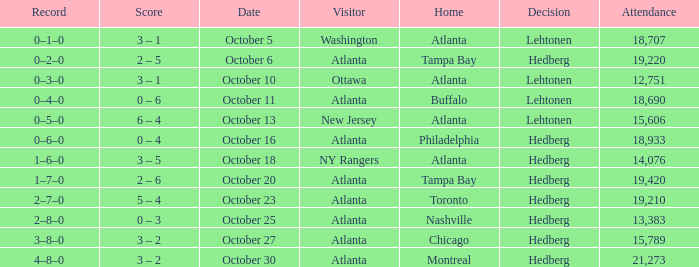What was the record on the game that was played on october 27? 3–8–0. 